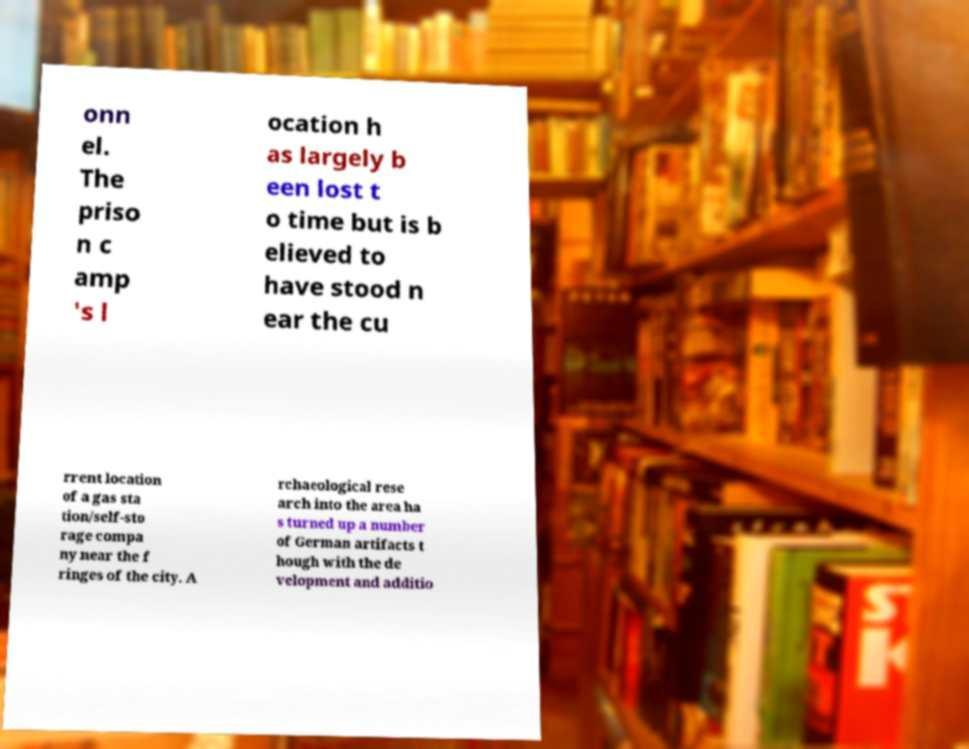What messages or text are displayed in this image? I need them in a readable, typed format. onn el. The priso n c amp 's l ocation h as largely b een lost t o time but is b elieved to have stood n ear the cu rrent location of a gas sta tion/self-sto rage compa ny near the f ringes of the city. A rchaeological rese arch into the area ha s turned up a number of German artifacts t hough with the de velopment and additio 